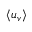Convert formula to latex. <formula><loc_0><loc_0><loc_500><loc_500>\left < u _ { v } \right ></formula> 